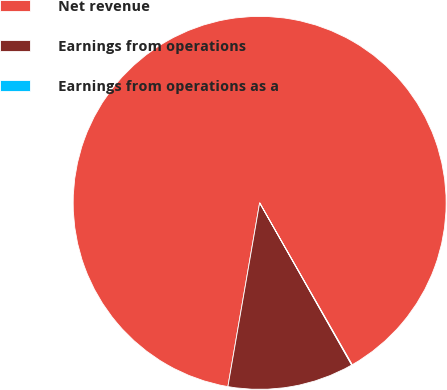Convert chart to OTSL. <chart><loc_0><loc_0><loc_500><loc_500><pie_chart><fcel>Net revenue<fcel>Earnings from operations<fcel>Earnings from operations as a<nl><fcel>89.02%<fcel>10.94%<fcel>0.05%<nl></chart> 